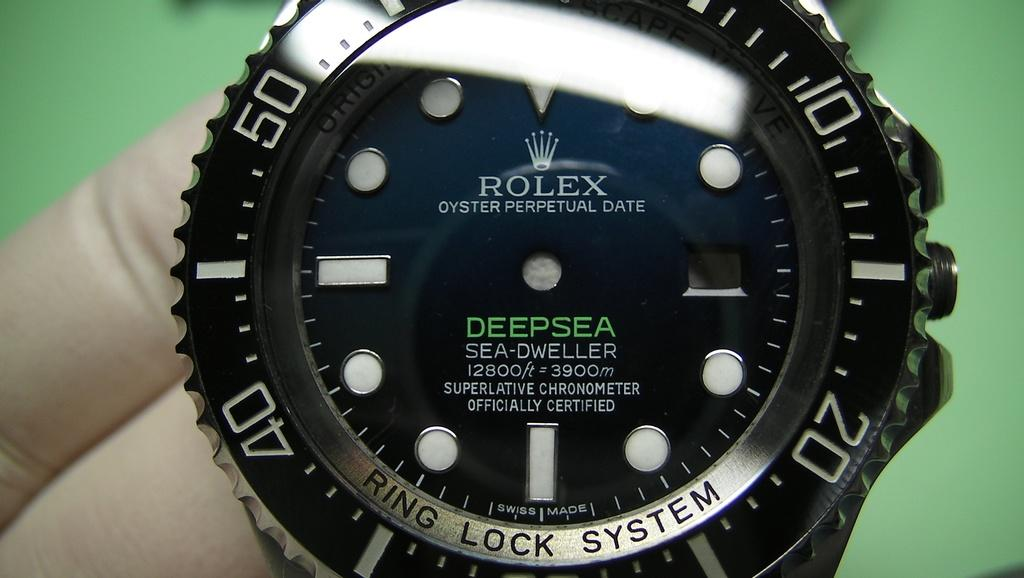<image>
Render a clear and concise summary of the photo. A person is holding a Rolex watch that says Oyster Perpetual Date. 